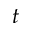Convert formula to latex. <formula><loc_0><loc_0><loc_500><loc_500>t</formula> 